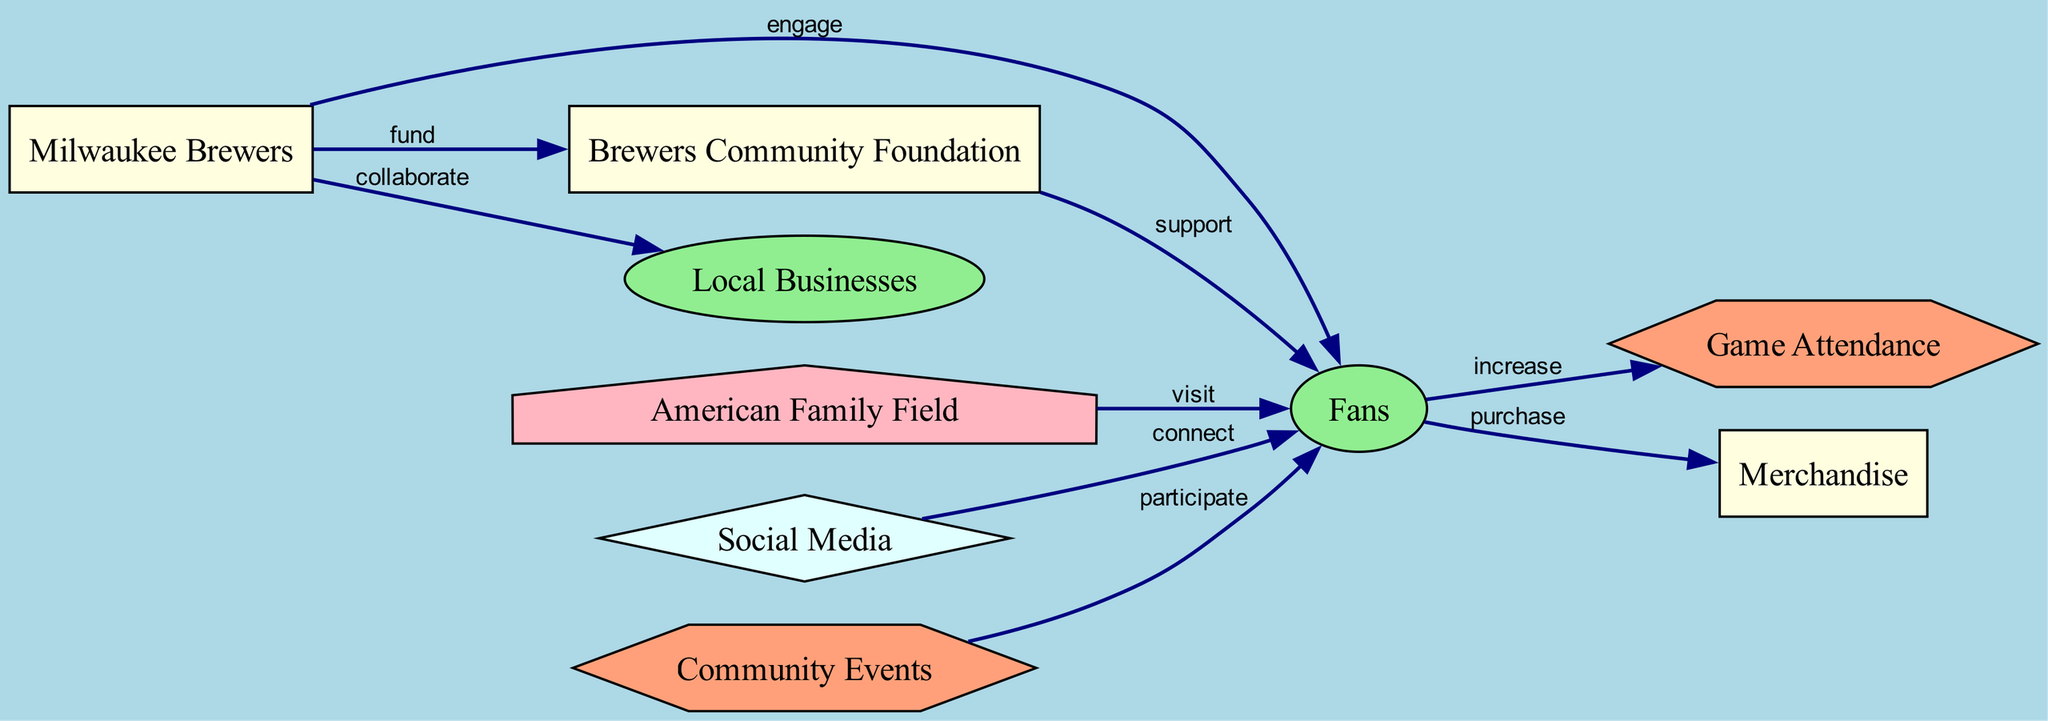What entity engages with fans? The diagram shows a directed edge from the "Milwaukee Brewers" node to the "Fans" node, indicating that the Brewers engage with their fans.
Answer: Milwaukee Brewers How many edges connect local businesses to fans? In the diagram, there is one directed edge from "Local Businesses" to "Fans," which represents the collaboration between them.
Answer: One What activity do fans participate in? The diagram indicates that fans participate in "Community Events" since there is a directed edge from the "Community Events" node to the "Fans" node.
Answer: Community Events Which group supports the fans? The diagram illustrates that the "Brewers Community Foundation" node has a directed edge towards the "Fans," indicating that this entity supports the fans.
Answer: Brewers Community Foundation What type of node is "American Family Field"? The node "American Family Field" is defined as a location type in the diagram based on the `type` attribute.
Answer: location What activity is increased by fans' game attendance? The diagram shows a directed edge from the "Fans" node to the "Game Attendance" node, indicating that the activity of attendance is increased by fans.
Answer: Game Attendance What two types of platforms connect with fans? The diagram includes "Social Media" as a platform that connects with fans and also indicates that the "Milwaukee Brewers" engage with fans directly, which is also a form of connection.
Answer: Social Media, Milwaukee Brewers Which activity is influenced by fans' connection with social media? According to the diagram, there's a relationship between "Social Media" and "Fans," which implies that social media influences fan interaction or engagement activities.
Answer: Connect What is the overall purpose of community events for fans? The diagram demonstrates that community events are a way for fans to participate in activities, indicating that engagement in community events serves as a method for active fan involvement.
Answer: Participate 